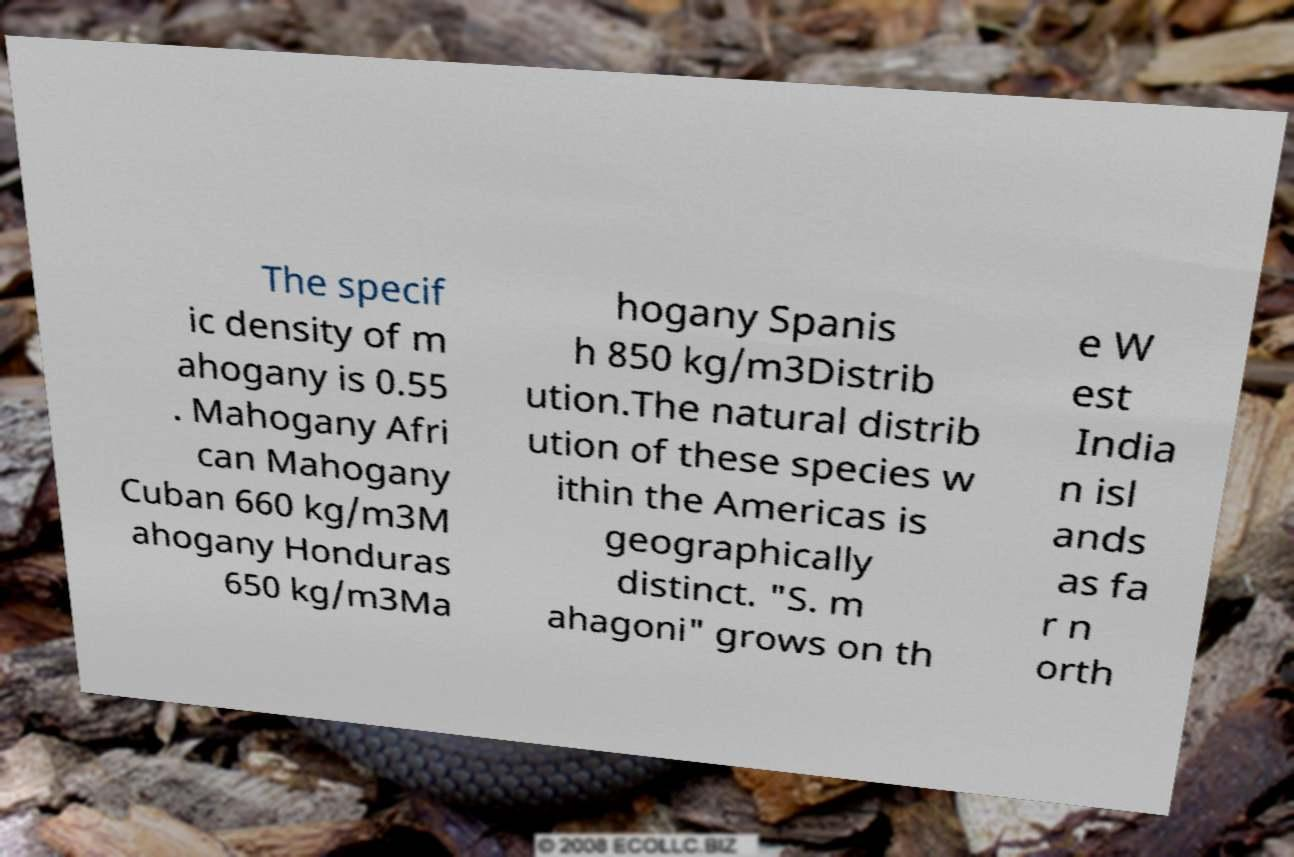What messages or text are displayed in this image? I need them in a readable, typed format. The specif ic density of m ahogany is 0.55 . Mahogany Afri can Mahogany Cuban 660 kg/m3M ahogany Honduras 650 kg/m3Ma hogany Spanis h 850 kg/m3Distrib ution.The natural distrib ution of these species w ithin the Americas is geographically distinct. "S. m ahagoni" grows on th e W est India n isl ands as fa r n orth 